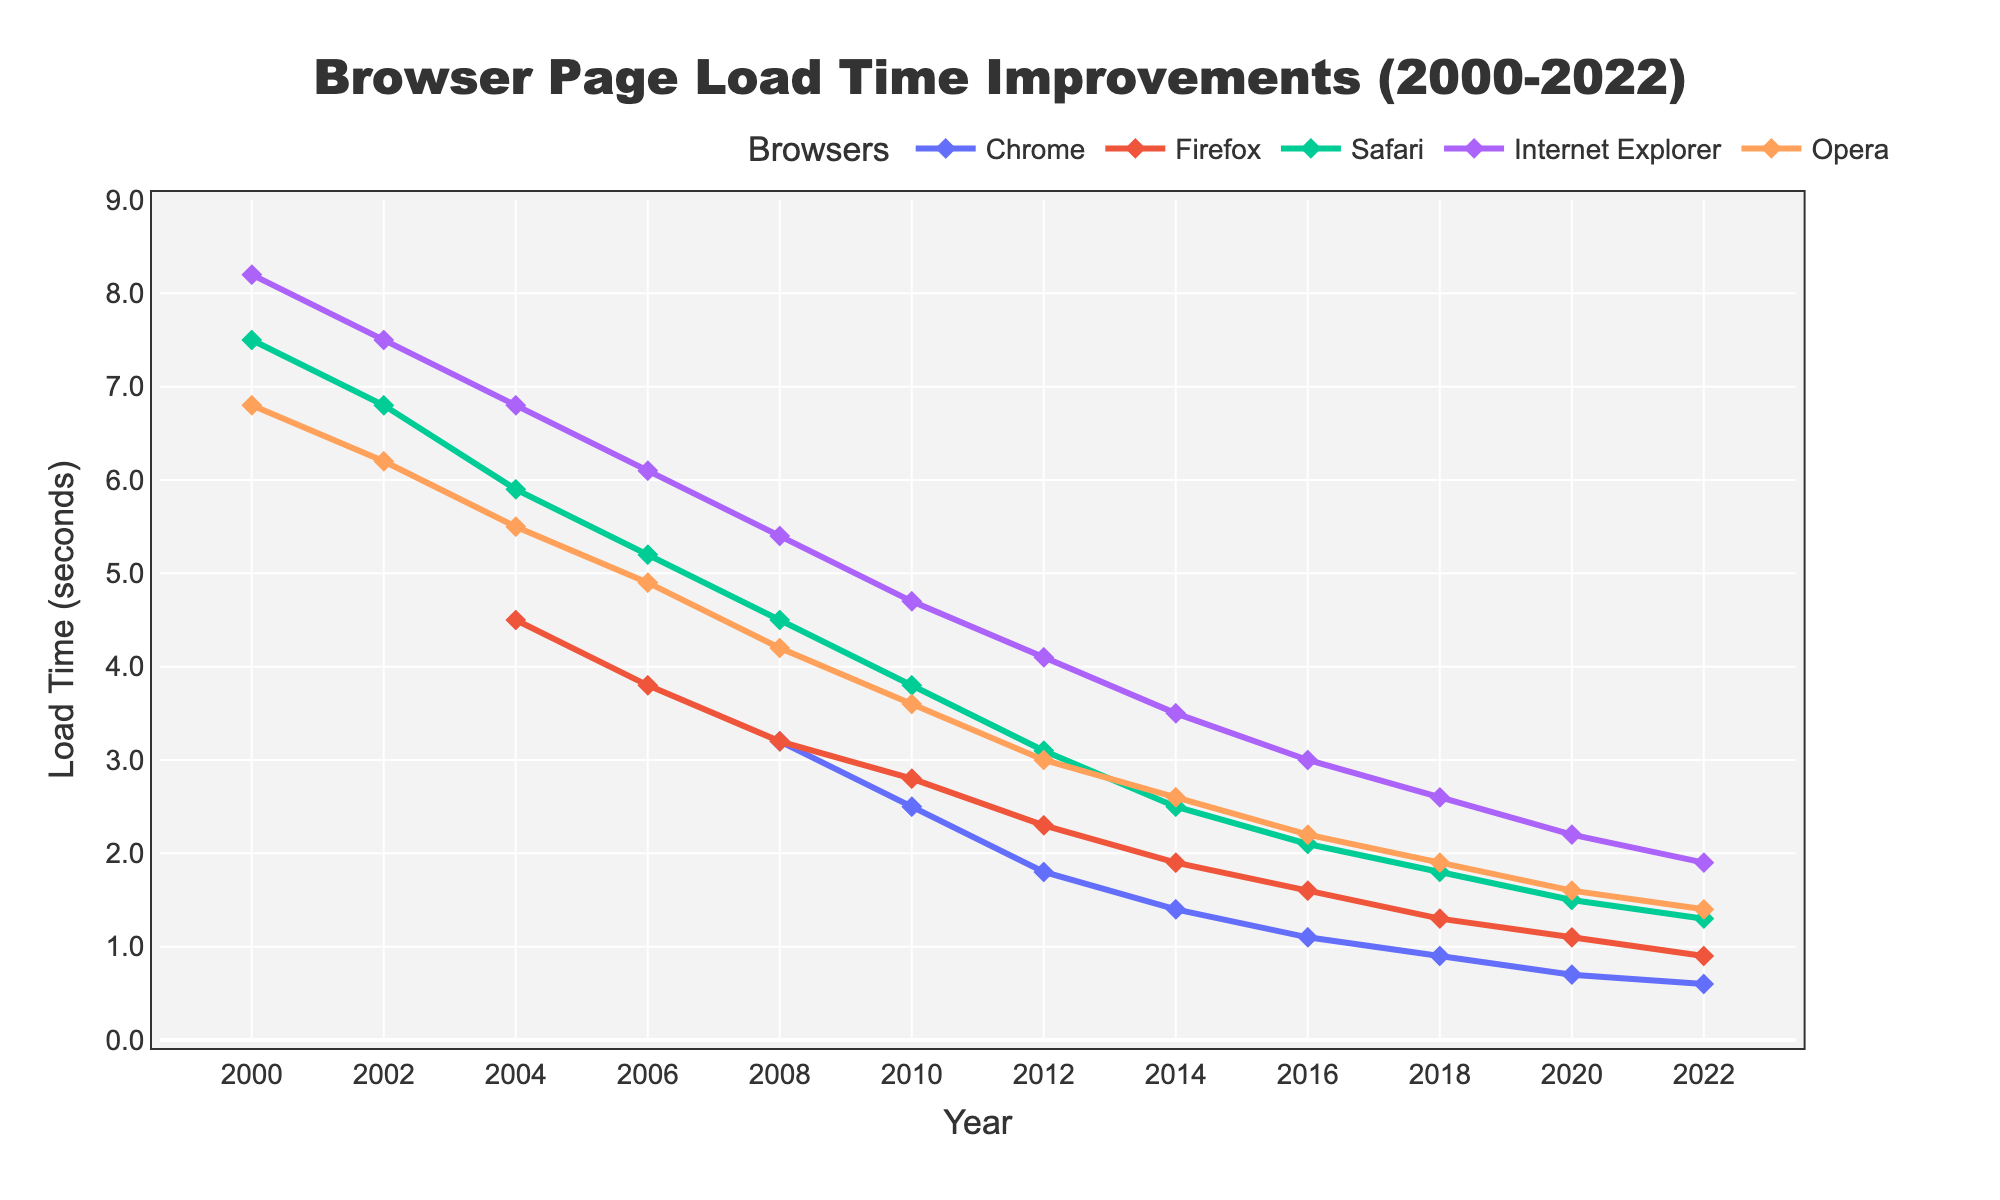What's the browser with the fastest page load time in 2022? To find the browser with the fastest page load time in 2022, look at the values for all the browsers in the year 2022. The browser with the lowest load time value is the fastest. Chrome has a load time of 0.6 seconds, which is the lowest.
Answer: Chrome How did Internet Explorer's page load time change from 2000 to 2022? To determine the change in page load time of Internet Explorer from 2000 to 2022, look at the values for these specific years: Internet Explorer had a load time of 8.2 seconds in 2000 and 1.9 seconds in 2022. Then calculate the difference: 8.2 - 1.9 = 6.3 seconds improvement.
Answer: Improved by 6.3 seconds Which browser had the most significant improvement in page load time between 2008 and 2022? Compare the page load times of each browser in 2008 and 2022. Subtract the 2022 times from the 2008 times to find the improvements: Chrome (2.6), Firefox (2.3), Safari (3.2), Internet Explorer (3.5), and Opera (2.8). The browser with the highest improvement is Internet Explorer with a reduction of 3.5 seconds.
Answer: Internet Explorer Between 2010 and 2020, which browser showed the least improvement in page load time? Calculate the difference in page load time for each browser from 2010 to 2020: Chrome (2.5 - 0.7 = 1.8), Firefox (2.8 - 1.1 = 1.7), Safari (3.8 - 1.5 = 2.3), Internet Explorer (4.7 - 2.2 = 2.5), Opera (3.6 - 1.6 = 2.0). Firefox showed the least improvement of 1.7 seconds.
Answer: Firefox Which year did Safari drop below a page load time of 3 seconds? Examine Safari's page load times over the years and identify the first year with a value below 3 seconds. In 2012, Safari's load time is 3.1 seconds, and in 2014 it drops to 2.5 seconds. Therefore, 2014 is the year it dropped below 3 seconds.
Answer: 2014 What was the average page load time for all browsers in 2004? To find the average, sum all the page load times for 2004 and divide by the number of browsers reporting times that year: (Firefox 4.5 + Safari 5.9 + Internet Explorer 6.8 + Opera 5.5) / 4 = 5.675 seconds.
Answer: 5.675 seconds Did any browser consistently improve every designated year from 2008 to 2022? Review each browser's page load time for every two-year interval from 2008 to 2022 and check if there is a consistent decrease. Chrome, Firefox, Safari, and Opera show consistent improvements every two years, while Internet Explorer also shows improvements consistently. Therefore, all listed browsers have shown consistent improvement.
Answer: Yes What's the difference in page load times between Opera and Firefox in 2012? Check the values for Opera and Firefox in 2012. Opera's load time is 3.0 seconds, and Firefox's load time is 2.3 seconds. The difference is 3.0 - 2.3 = 0.7 seconds.
Answer: 0.7 seconds 